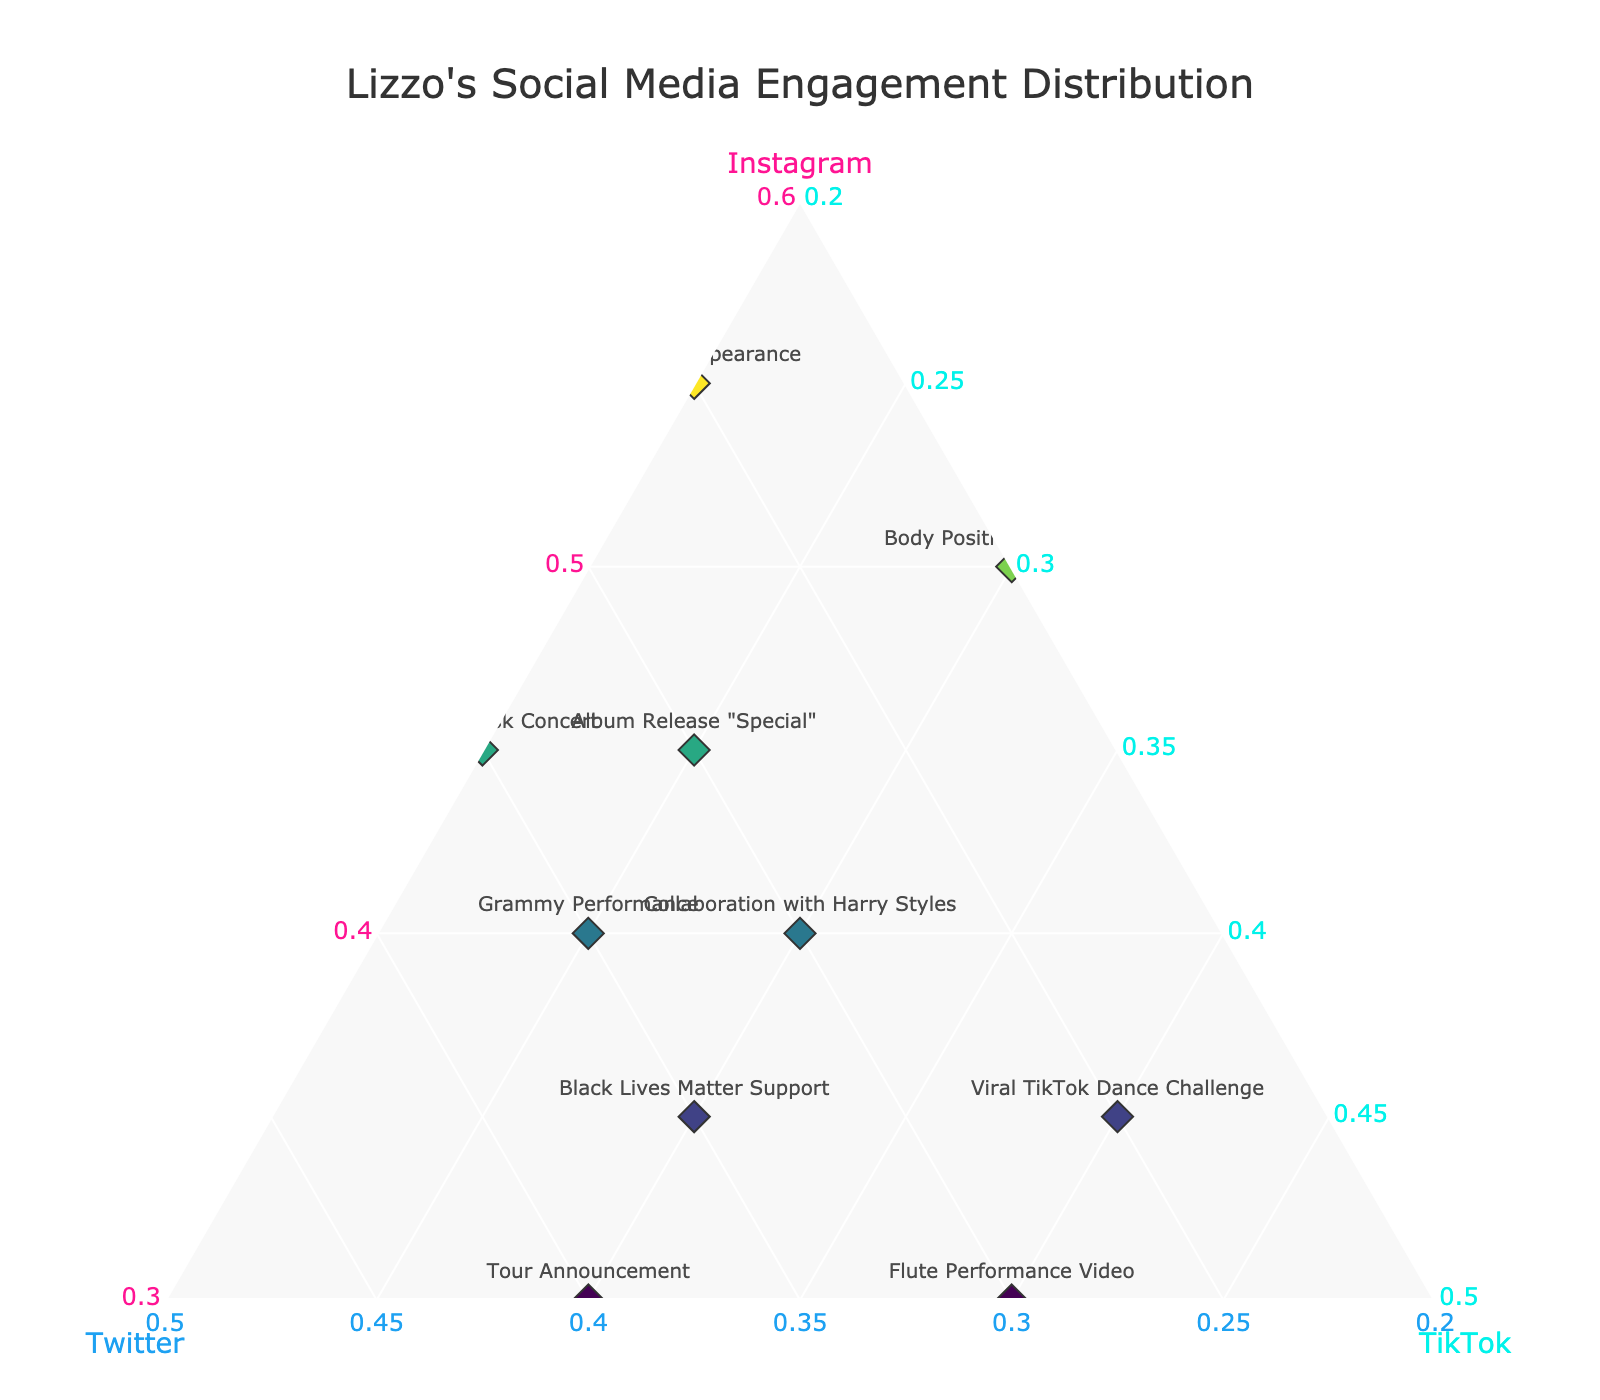what is the title of the figure? The title is positioned at the top of the figure and clearly states what the plot is about. In this case, it reads "Lizzo's Social Media Engagement Distribution".
Answer: Lizzo's Social Media Engagement Distribution how many events are plotted in the figure? By counting the markers for each event in the ternary plot, we find that there are 10 unique events visualized.
Answer: 10 which event shows the highest engagement on Instagram? Look for the marker closest to the Instagram vertex. The "Met Gala Appearance" event has the highest Instagram engagement at 55%.
Answer: Met Gala Appearance what is the engagement percentage for TikTok during the black lives matter support event? Find the point labeled "Black Lives Matter Support" and observe the TikTok engagement percentage, which is 30%.
Answer: 30% what color represents the Twitter axis? Look at the label and line color for the Twitter axis, which is highlighted in a specific color, namely light blue.
Answer: Light blue what is the combined engagement percentage for Instagram and TikTok during the viral tiktok dance challenge event? The Viral TikTok Dance Challenge has Instagram at 35% and TikTok at 40%. Adding these two percentages gives 35 + 40 = 75.
Answer: 75 how does the engagement distribution compare between the grammy performance and the tour announcement events? The Grammy Performance has an engagement of 40% on Instagram, 35% on Twitter, and 25% on TikTok; the Tour Announcement has 30% on Instagram, 40% on Twitter, and 30% on TikTok. Comparing these, the Grammy Performance has higher Instagram engagement, the Tour Announcement has higher Twitter engagement, and they are equal on TikTok.
Answer: Instagram: Grammy > Tour; Twitter: Tour > Grammy; TikTok: equal which event has the most balanced engagement across all three platforms? Look for the event closest to the center of the ternary plot, where the percentages for Instagram, Twitter, and TikTok are closest to being equal. The "Collaboration with Harry Styles" event is closest to this point with 40% Instagram, 30% Twitter, and 30% TikTok.
Answer: Collaboration with Harry Styles what is the total engagement percentage for the body positivity campaign event across all platforms? Sum the individual engagement percentages: 50% on Instagram, 20% on Twitter, and 30% on TikTok. Therefore, 50 + 20 + 30 = 100.
Answer: 100 which event shows the least engagement on twitter? Identify the marker farthest from the Twitter vertex. The "Met Gala Appearance" event, with 25% Twitter engagement, shares this minimum percentage.
Answer: Met Gala Appearance 